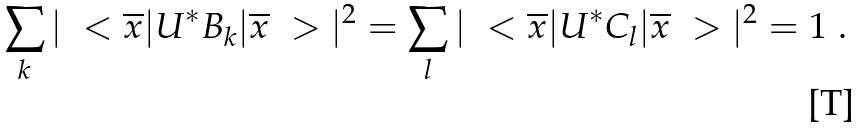Convert formula to latex. <formula><loc_0><loc_0><loc_500><loc_500>\sum _ { k } | \ < \overline { x } | U ^ { * } B _ { k } | \overline { x } \ > | ^ { 2 } = \sum _ { l } | \ < \overline { x } | U ^ { * } C _ { l } | \overline { x } \ > | ^ { 2 } = 1 \ .</formula> 